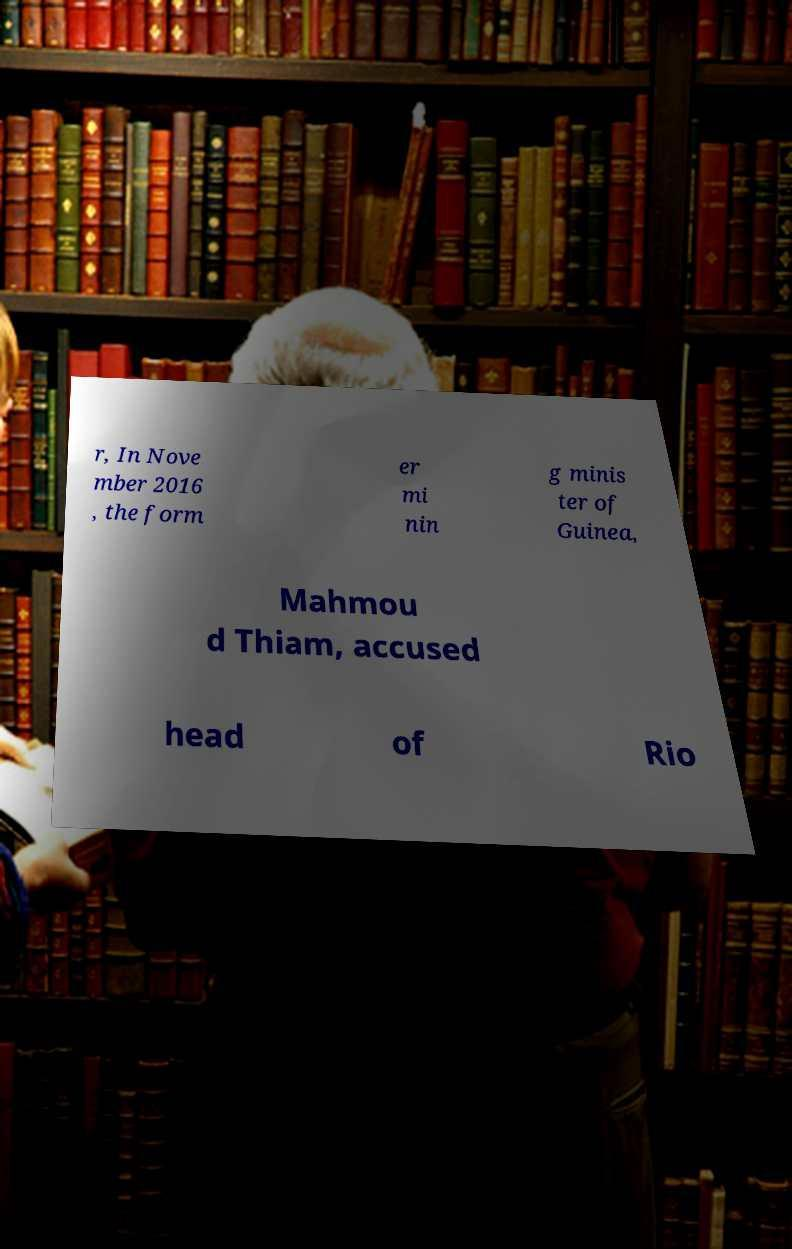There's text embedded in this image that I need extracted. Can you transcribe it verbatim? r, In Nove mber 2016 , the form er mi nin g minis ter of Guinea, Mahmou d Thiam, accused head of Rio 